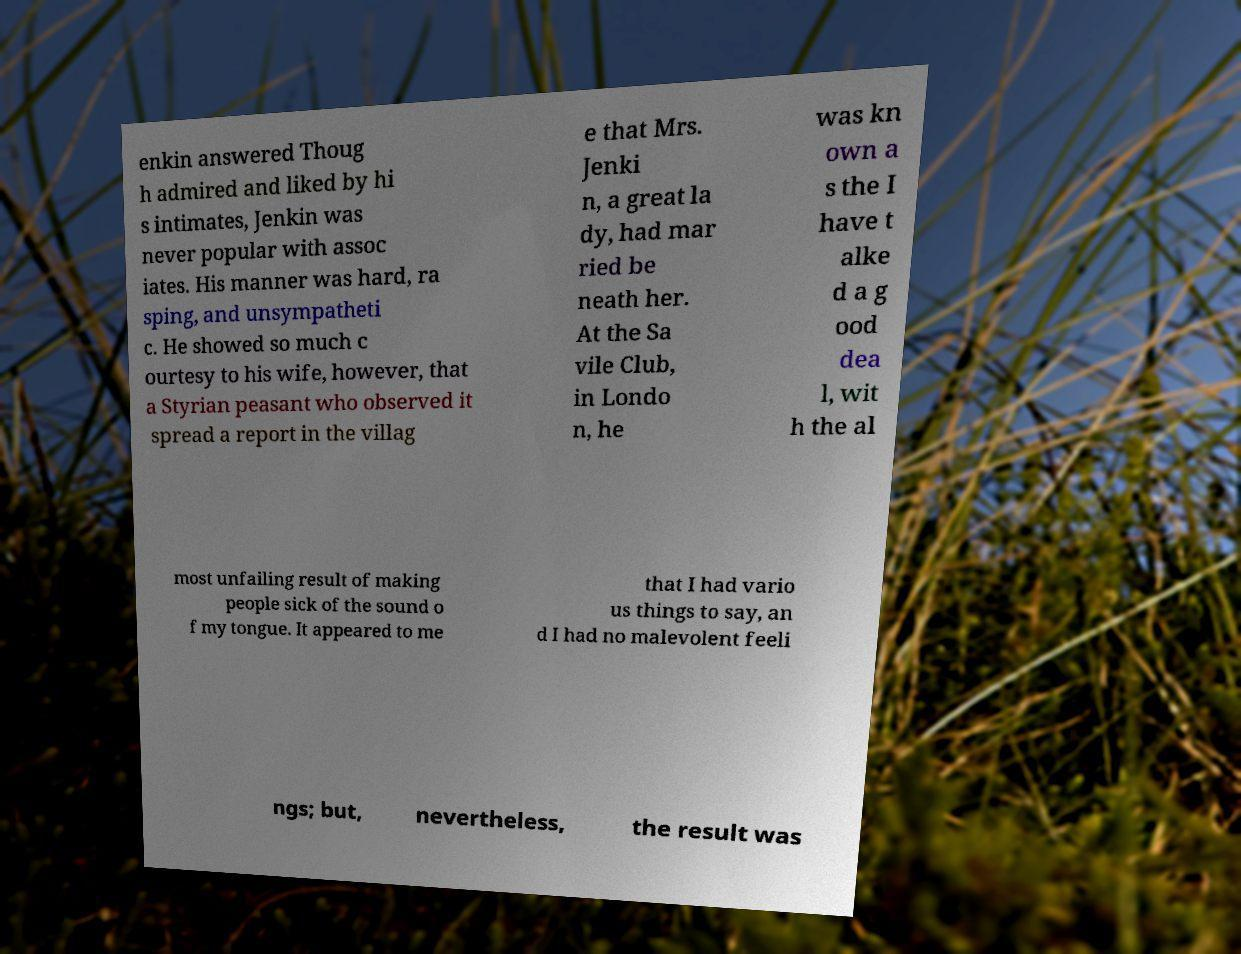Can you read and provide the text displayed in the image?This photo seems to have some interesting text. Can you extract and type it out for me? enkin answered Thoug h admired and liked by hi s intimates, Jenkin was never popular with assoc iates. His manner was hard, ra sping, and unsympatheti c. He showed so much c ourtesy to his wife, however, that a Styrian peasant who observed it spread a report in the villag e that Mrs. Jenki n, a great la dy, had mar ried be neath her. At the Sa vile Club, in Londo n, he was kn own a s the I have t alke d a g ood dea l, wit h the al most unfailing result of making people sick of the sound o f my tongue. It appeared to me that I had vario us things to say, an d I had no malevolent feeli ngs; but, nevertheless, the result was 